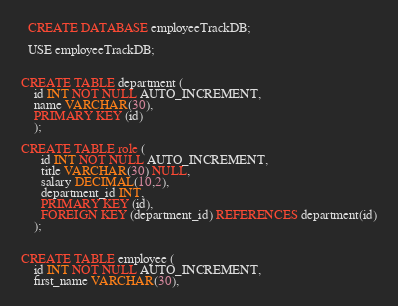<code> <loc_0><loc_0><loc_500><loc_500><_SQL_>  CREATE DATABASE employeeTrackDB;

  USE employeeTrackDB;
  
  
CREATE TABLE department (
    id INT NOT NULL AUTO_INCREMENT,
    name VARCHAR(30),
    PRIMARY KEY (id)
    );
 
CREATE TABLE role (
      id INT NOT NULL AUTO_INCREMENT,
      title VARCHAR(30) NULL,
      salary DECIMAL(10,2),
      department_id INT,
      PRIMARY KEY (id),
      FOREIGN KEY (department_id) REFERENCES department(id)
    );


CREATE TABLE employee (
    id INT NOT NULL AUTO_INCREMENT,
    first_name VARCHAR(30),</code> 